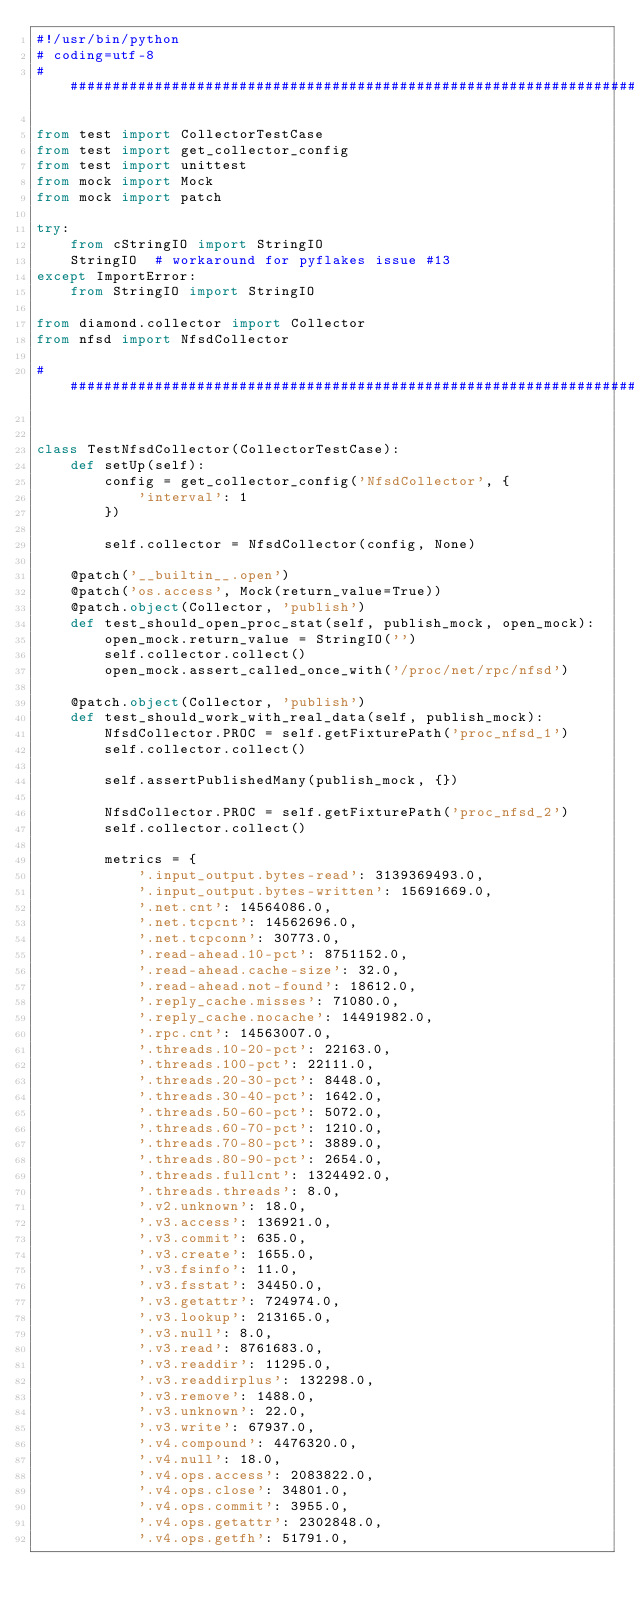<code> <loc_0><loc_0><loc_500><loc_500><_Python_>#!/usr/bin/python
# coding=utf-8
################################################################################

from test import CollectorTestCase
from test import get_collector_config
from test import unittest
from mock import Mock
from mock import patch

try:
    from cStringIO import StringIO
    StringIO  # workaround for pyflakes issue #13
except ImportError:
    from StringIO import StringIO

from diamond.collector import Collector
from nfsd import NfsdCollector

################################################################################


class TestNfsdCollector(CollectorTestCase):
    def setUp(self):
        config = get_collector_config('NfsdCollector', {
            'interval': 1
        })

        self.collector = NfsdCollector(config, None)

    @patch('__builtin__.open')
    @patch('os.access', Mock(return_value=True))
    @patch.object(Collector, 'publish')
    def test_should_open_proc_stat(self, publish_mock, open_mock):
        open_mock.return_value = StringIO('')
        self.collector.collect()
        open_mock.assert_called_once_with('/proc/net/rpc/nfsd')

    @patch.object(Collector, 'publish')
    def test_should_work_with_real_data(self, publish_mock):
        NfsdCollector.PROC = self.getFixturePath('proc_nfsd_1')
        self.collector.collect()

        self.assertPublishedMany(publish_mock, {})

        NfsdCollector.PROC = self.getFixturePath('proc_nfsd_2')
        self.collector.collect()

        metrics = {
            '.input_output.bytes-read': 3139369493.0,
            '.input_output.bytes-written': 15691669.0,
            '.net.cnt': 14564086.0,
            '.net.tcpcnt': 14562696.0,
            '.net.tcpconn': 30773.0,
            '.read-ahead.10-pct': 8751152.0,
            '.read-ahead.cache-size': 32.0,
            '.read-ahead.not-found': 18612.0,
            '.reply_cache.misses': 71080.0,
            '.reply_cache.nocache': 14491982.0,
            '.rpc.cnt': 14563007.0,
            '.threads.10-20-pct': 22163.0,
            '.threads.100-pct': 22111.0,
            '.threads.20-30-pct': 8448.0,
            '.threads.30-40-pct': 1642.0,
            '.threads.50-60-pct': 5072.0,
            '.threads.60-70-pct': 1210.0,
            '.threads.70-80-pct': 3889.0,
            '.threads.80-90-pct': 2654.0,
            '.threads.fullcnt': 1324492.0,
            '.threads.threads': 8.0,
            '.v2.unknown': 18.0,
            '.v3.access': 136921.0,
            '.v3.commit': 635.0,
            '.v3.create': 1655.0,
            '.v3.fsinfo': 11.0,
            '.v3.fsstat': 34450.0,
            '.v3.getattr': 724974.0,
            '.v3.lookup': 213165.0,
            '.v3.null': 8.0,
            '.v3.read': 8761683.0,
            '.v3.readdir': 11295.0,
            '.v3.readdirplus': 132298.0,
            '.v3.remove': 1488.0,
            '.v3.unknown': 22.0,
            '.v3.write': 67937.0,
            '.v4.compound': 4476320.0,
            '.v4.null': 18.0,
            '.v4.ops.access': 2083822.0,
            '.v4.ops.close': 34801.0,
            '.v4.ops.commit': 3955.0,
            '.v4.ops.getattr': 2302848.0,
            '.v4.ops.getfh': 51791.0,</code> 